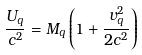<formula> <loc_0><loc_0><loc_500><loc_500>\frac { U _ { q } } { c ^ { 2 } } = M _ { q } \left ( 1 + \frac { v _ { q } ^ { 2 } } { 2 c ^ { 2 } } \right )</formula> 